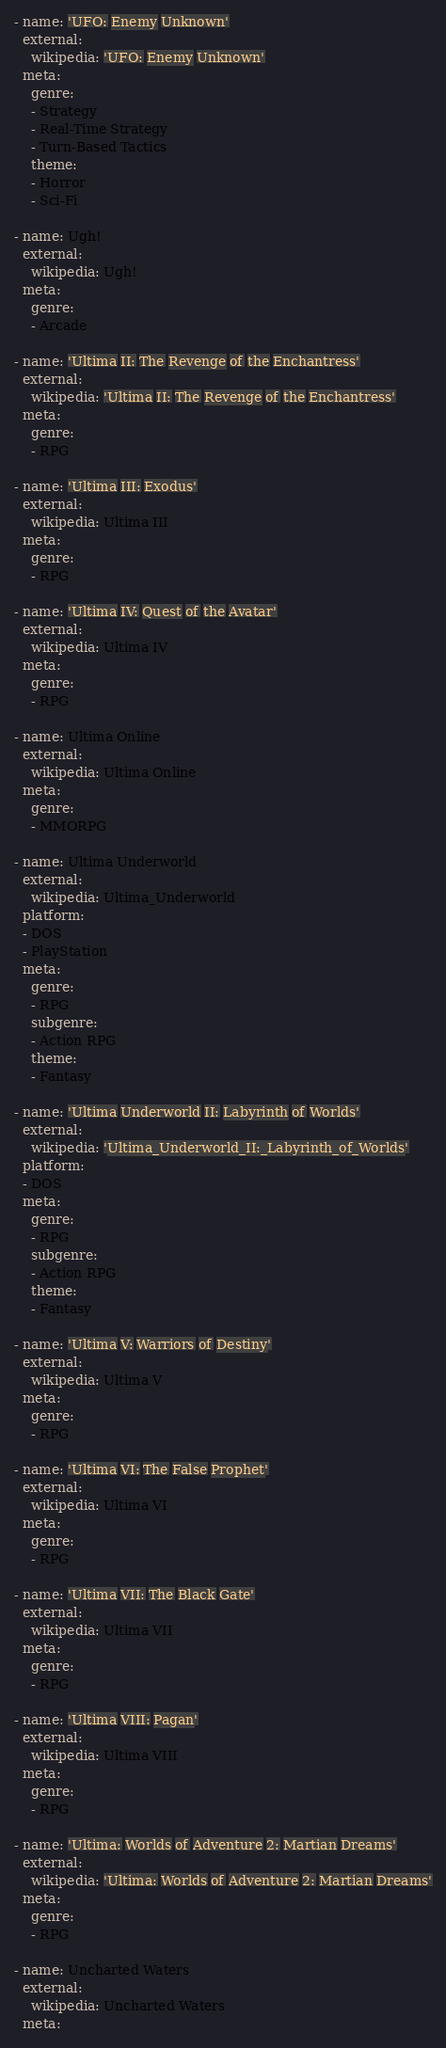Convert code to text. <code><loc_0><loc_0><loc_500><loc_500><_YAML_>- name: 'UFO: Enemy Unknown'
  external:
    wikipedia: 'UFO: Enemy Unknown'
  meta:
    genre:
    - Strategy
    - Real-Time Strategy
    - Turn-Based Tactics
    theme:
    - Horror
    - Sci-Fi

- name: Ugh!
  external:
    wikipedia: Ugh!
  meta:
    genre:
    - Arcade

- name: 'Ultima II: The Revenge of the Enchantress'
  external:
    wikipedia: 'Ultima II: The Revenge of the Enchantress'
  meta:
    genre:
    - RPG

- name: 'Ultima III: Exodus'
  external:
    wikipedia: Ultima III
  meta:
    genre:
    - RPG

- name: 'Ultima IV: Quest of the Avatar'
  external:
    wikipedia: Ultima IV
  meta:
    genre:
    - RPG

- name: Ultima Online
  external:
    wikipedia: Ultima Online
  meta:
    genre:
    - MMORPG
    
- name: Ultima Underworld
  external:
    wikipedia: Ultima_Underworld
  platform:
  - DOS
  - PlayStation
  meta:
    genre:
    - RPG
    subgenre:
    - Action RPG
    theme:
    - Fantasy
    
- name: 'Ultima Underworld II: Labyrinth of Worlds'
  external:
    wikipedia: 'Ultima_Underworld_II:_Labyrinth_of_Worlds'
  platform:
  - DOS
  meta:
    genre:
    - RPG
    subgenre:
    - Action RPG
    theme:
    - Fantasy

- name: 'Ultima V: Warriors of Destiny'
  external:
    wikipedia: Ultima V
  meta:
    genre:
    - RPG

- name: 'Ultima VI: The False Prophet'
  external:
    wikipedia: Ultima VI
  meta:
    genre:
    - RPG

- name: 'Ultima VII: The Black Gate'
  external:
    wikipedia: Ultima VII
  meta:
    genre:
    - RPG

- name: 'Ultima VIII: Pagan'
  external:
    wikipedia: Ultima VIII
  meta:
    genre:
    - RPG

- name: 'Ultima: Worlds of Adventure 2: Martian Dreams'
  external:
    wikipedia: 'Ultima: Worlds of Adventure 2: Martian Dreams'
  meta:
    genre:
    - RPG

- name: Uncharted Waters
  external:
    wikipedia: Uncharted Waters
  meta:</code> 